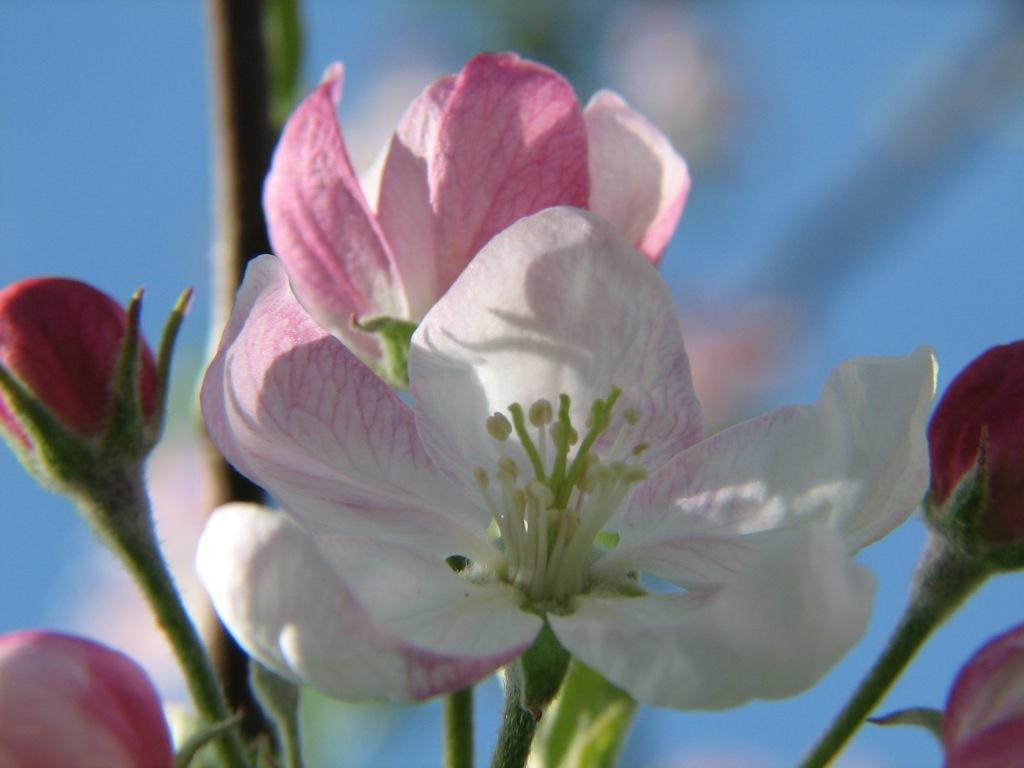What type of flora is present in the image? There are beautiful flowers in the image. Can you describe the stage of growth of the flowers? There are flower buds in the image, indicating that some flowers are still in the process of blooming. Where are the flowers located? The flowers are on a plant. What colors can be seen in the flowers? The flowers are pink and white in color. What type of beast can be seen licking its wound in the image? There is no beast or wound present in the image; it features beautiful flowers on a plant. 